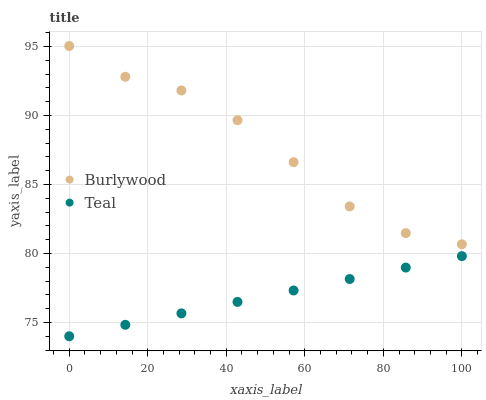Does Teal have the minimum area under the curve?
Answer yes or no. Yes. Does Burlywood have the maximum area under the curve?
Answer yes or no. Yes. Does Teal have the maximum area under the curve?
Answer yes or no. No. Is Teal the smoothest?
Answer yes or no. Yes. Is Burlywood the roughest?
Answer yes or no. Yes. Is Teal the roughest?
Answer yes or no. No. Does Teal have the lowest value?
Answer yes or no. Yes. Does Burlywood have the highest value?
Answer yes or no. Yes. Does Teal have the highest value?
Answer yes or no. No. Is Teal less than Burlywood?
Answer yes or no. Yes. Is Burlywood greater than Teal?
Answer yes or no. Yes. Does Teal intersect Burlywood?
Answer yes or no. No. 